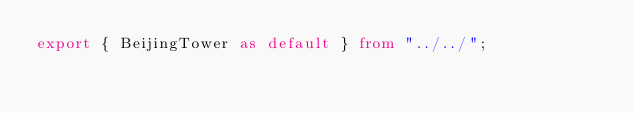<code> <loc_0><loc_0><loc_500><loc_500><_TypeScript_>export { BeijingTower as default } from "../../";
</code> 